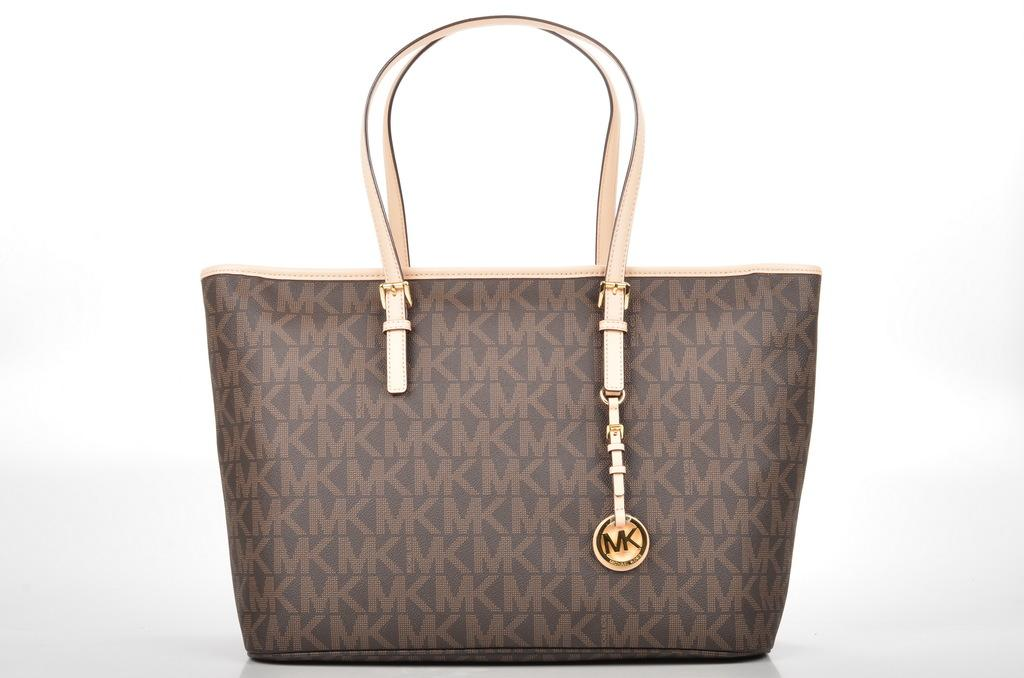What is the main object visible in the image? There is a handbag in the image. What color is the paint on the face of the person holding the handbag in the image? There is no person or face present in the image, as it only features a handbag. 